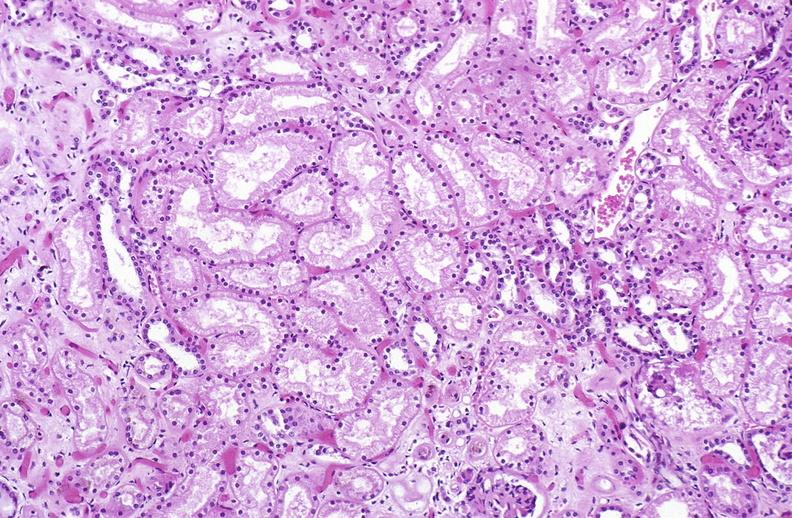what is present?
Answer the question using a single word or phrase. Urinary 